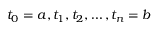Convert formula to latex. <formula><loc_0><loc_0><loc_500><loc_500>t _ { 0 } = a , t _ { 1 } , t _ { 2 } , \dots , t _ { n } = b</formula> 